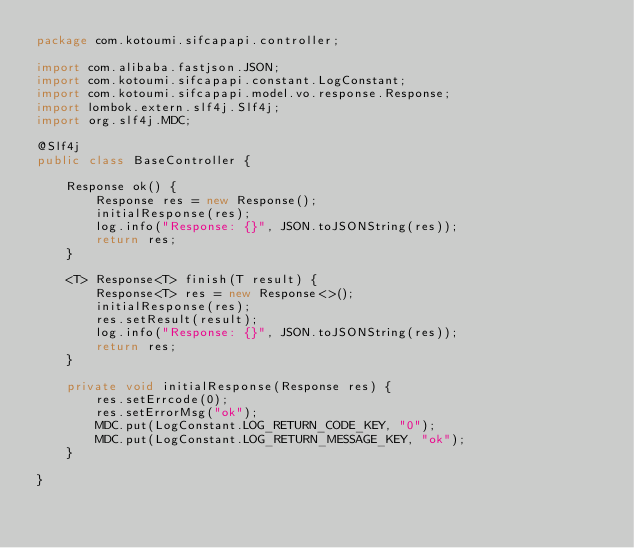Convert code to text. <code><loc_0><loc_0><loc_500><loc_500><_Java_>package com.kotoumi.sifcapapi.controller;

import com.alibaba.fastjson.JSON;
import com.kotoumi.sifcapapi.constant.LogConstant;
import com.kotoumi.sifcapapi.model.vo.response.Response;
import lombok.extern.slf4j.Slf4j;
import org.slf4j.MDC;

@Slf4j
public class BaseController {

    Response ok() {
        Response res = new Response();
        initialResponse(res);
        log.info("Response: {}", JSON.toJSONString(res));
        return res;
    }

    <T> Response<T> finish(T result) {
        Response<T> res = new Response<>();
        initialResponse(res);
        res.setResult(result);
        log.info("Response: {}", JSON.toJSONString(res));
        return res;
    }

    private void initialResponse(Response res) {
        res.setErrcode(0);
        res.setErrorMsg("ok");
        MDC.put(LogConstant.LOG_RETURN_CODE_KEY, "0");
        MDC.put(LogConstant.LOG_RETURN_MESSAGE_KEY, "ok");
    }

}
</code> 